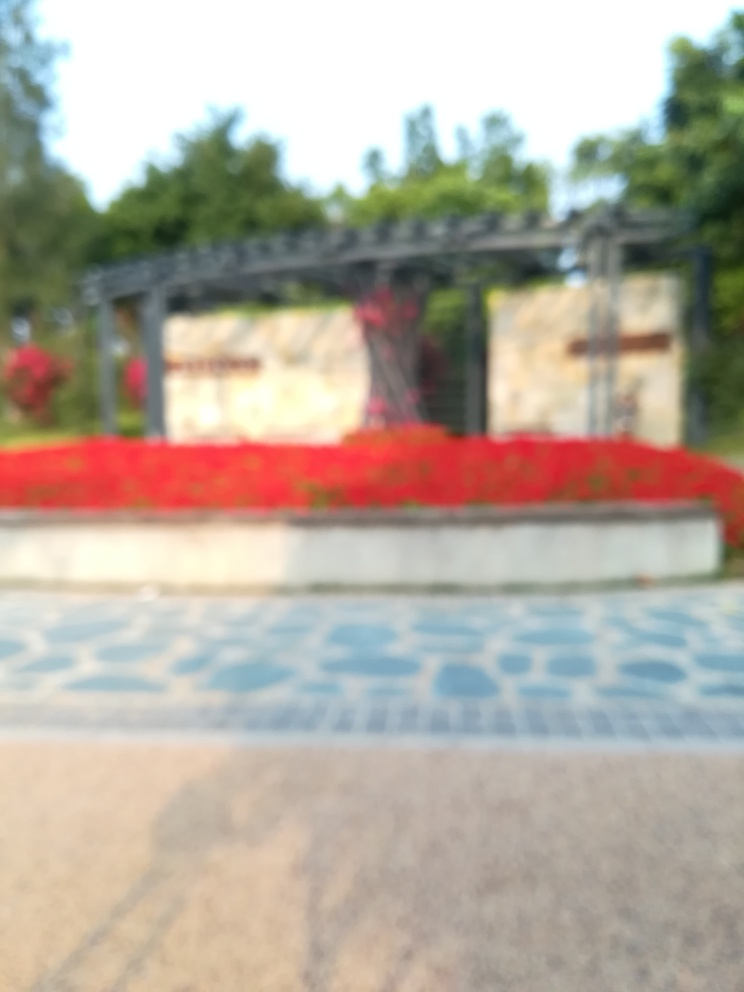What time of day does this image appear to have been taken? Given the image's overall bright appearance, one might speculate that it was taken during the daytime when the sun is likely to provide a strong light source. However, due to the blurriness, it is not possible to determine the time of day with precision. 